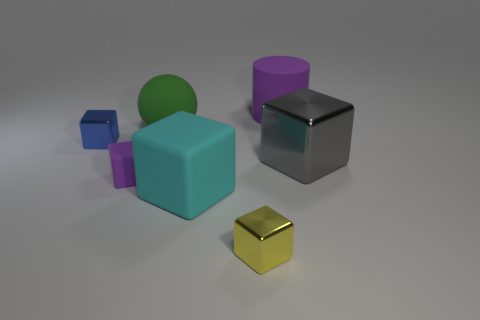How many big blocks have the same color as the large shiny thing?
Ensure brevity in your answer.  0. There is a tiny rubber thing that is the same shape as the gray metal object; what is its color?
Give a very brief answer. Purple. Do the yellow metallic block and the blue object have the same size?
Offer a terse response. Yes. Is the number of purple cubes in front of the purple cube the same as the number of gray shiny objects that are behind the green rubber sphere?
Ensure brevity in your answer.  Yes. Are any large blue cubes visible?
Offer a very short reply. No. What size is the purple object that is the same shape as the small blue object?
Provide a short and direct response. Small. There is a metal thing behind the gray metallic cube; what size is it?
Offer a terse response. Small. Are there more metal blocks that are behind the large gray metal block than big cyan matte cubes?
Provide a short and direct response. No. What shape is the large cyan object?
Give a very brief answer. Cube. Do the big rubber object in front of the green matte sphere and the large rubber cylinder that is right of the tiny yellow block have the same color?
Your answer should be compact. No. 